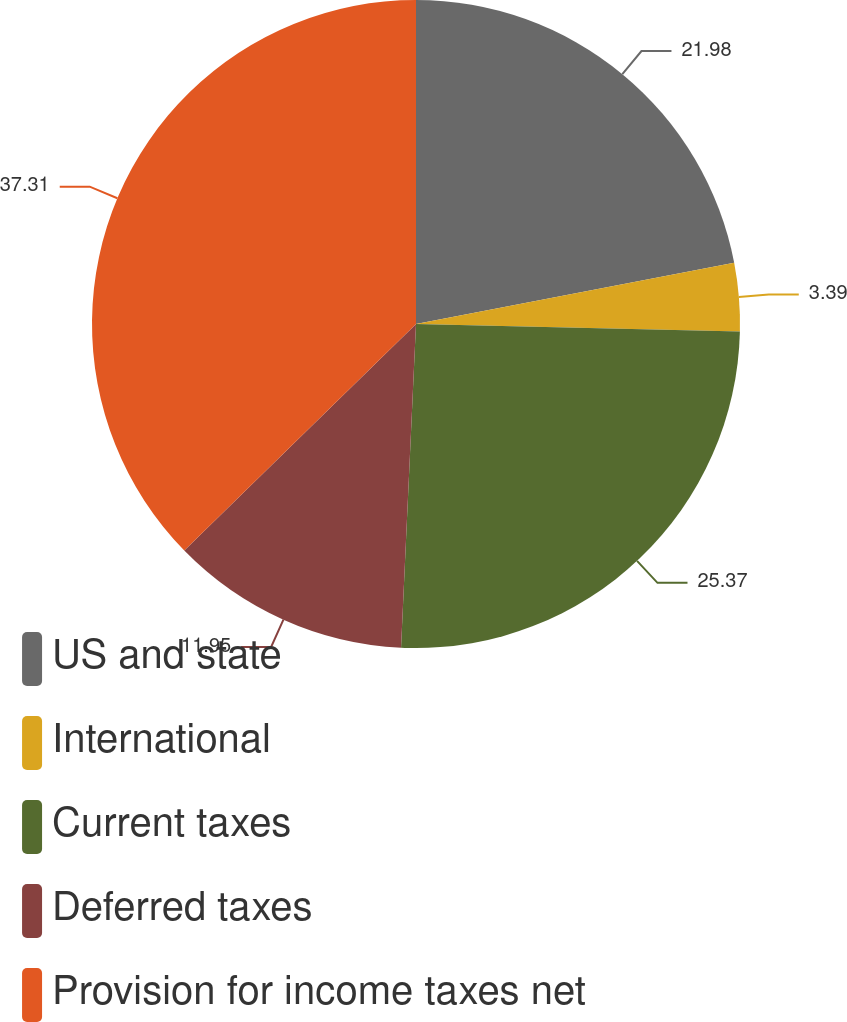Convert chart. <chart><loc_0><loc_0><loc_500><loc_500><pie_chart><fcel>US and state<fcel>International<fcel>Current taxes<fcel>Deferred taxes<fcel>Provision for income taxes net<nl><fcel>21.98%<fcel>3.39%<fcel>25.37%<fcel>11.95%<fcel>37.32%<nl></chart> 